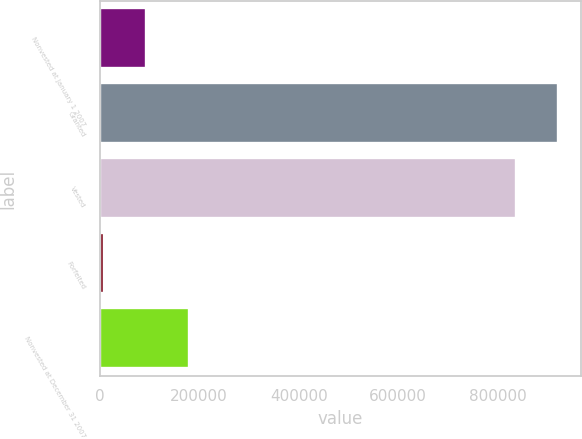Convert chart to OTSL. <chart><loc_0><loc_0><loc_500><loc_500><bar_chart><fcel>Nonvested at January 1 2007<fcel>Granted<fcel>Vested<fcel>Forfeited<fcel>Nonvested at December 31 2007<nl><fcel>93793.4<fcel>921040<fcel>835936<fcel>8689<fcel>178898<nl></chart> 